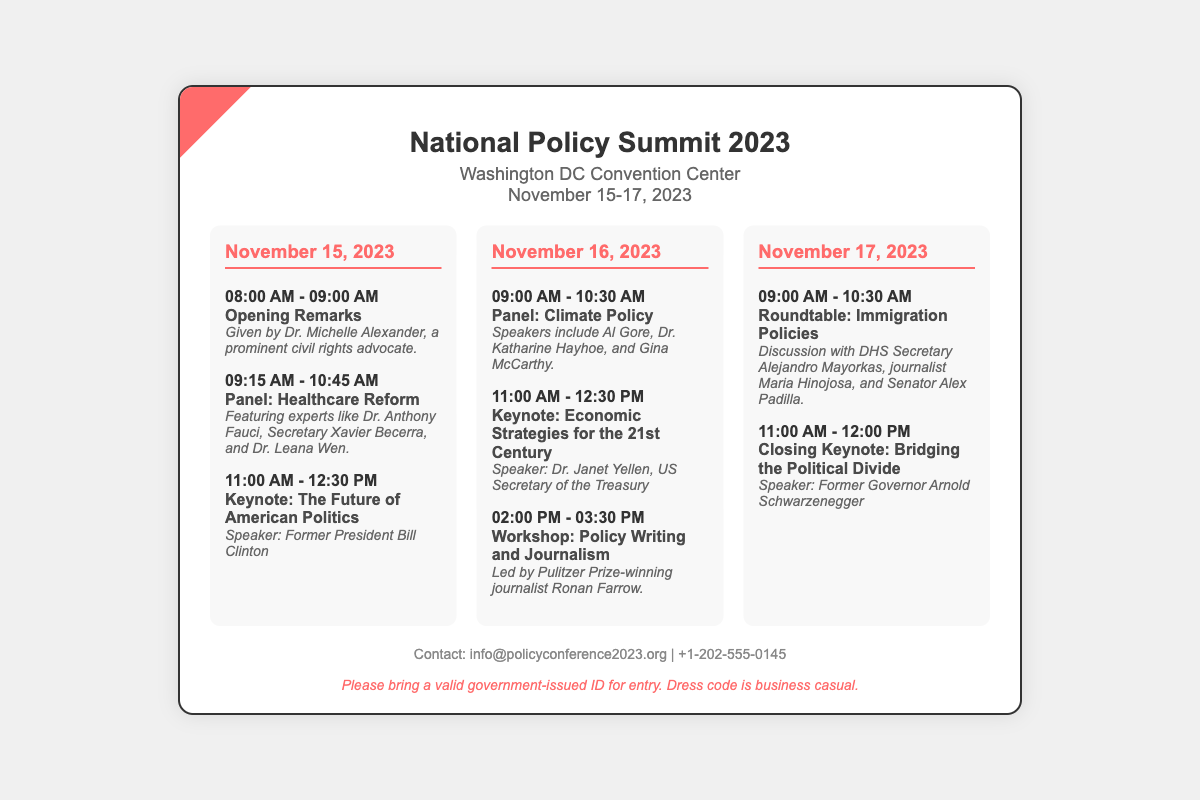What is the venue of the conference? The venue is stated in the document as the location where the event will be held.
Answer: Washington DC Convention Center What are the dates of the conference? The dates indicate when the policy conference will take place.
Answer: November 15-17, 2023 Who is the keynote speaker for the opening remarks? The document mentions who will give the opening remarks at the conference.
Answer: Dr. Michelle Alexander What time does the healthcare reform panel start on November 15? The time indicates when the specific panel on healthcare reform begins.
Answer: 09:15 AM Which topic is covered in the workshop led by Ronan Farrow? The workshop topic is specified in the document and details the subject matter to be discussed.
Answer: Policy Writing and Journalism How many days is the National Policy Summit 2023? The duration of the event can be determined from the dates provided in the document.
Answer: Three days Who will discuss immigration policies at the roundtable? The document outlines the participants in the roundtable discussion on immigration policies.
Answer: DHS Secretary Alejandro Mayorkas, journalist Maria Hinojosa, and Senator Alex Padilla What is the dress code for the event? The dress code is mentioned towards the end of the document, indicating what attendees should wear.
Answer: Business casual What is the contact email for the conference? The document provides a way for attendees to reach out for more information.
Answer: info@policyconference2023.org 